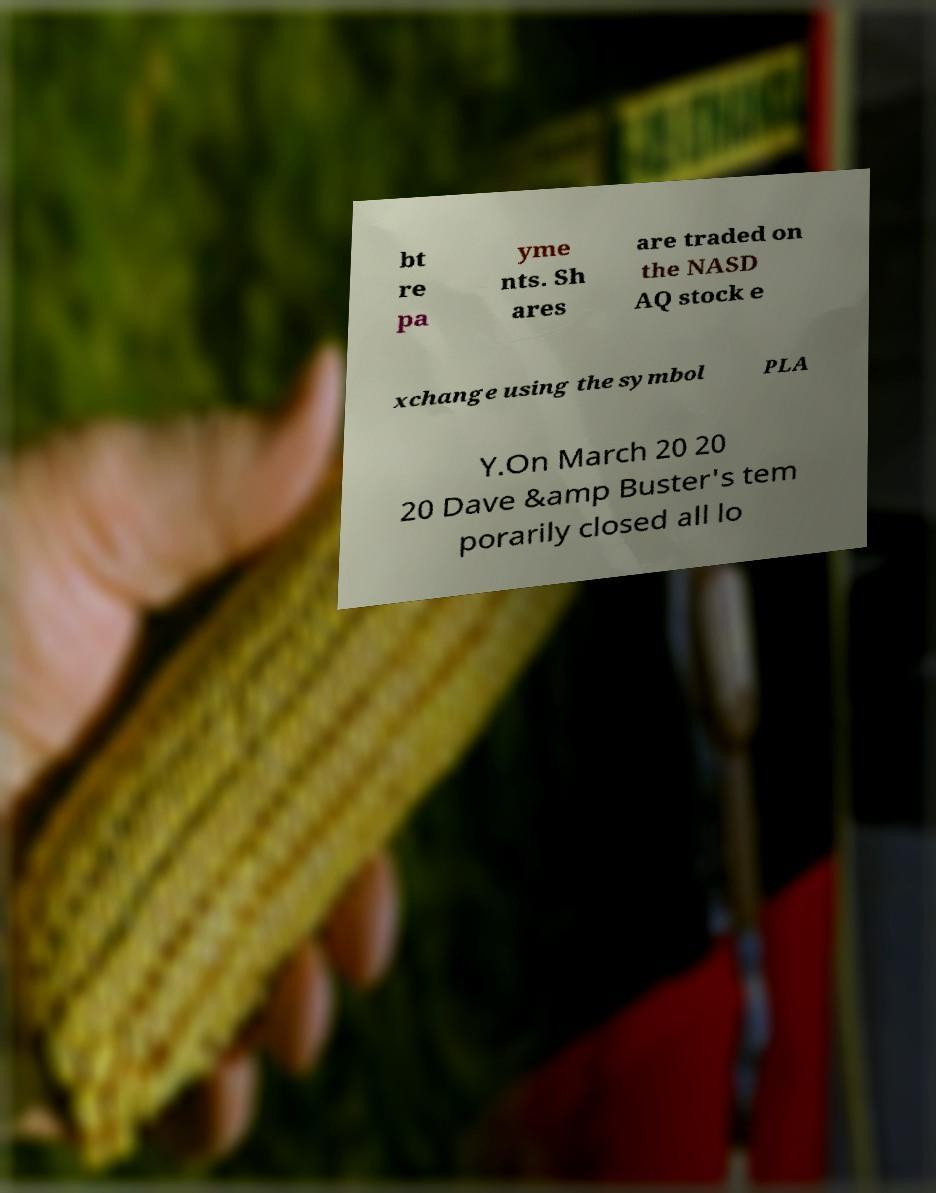Can you accurately transcribe the text from the provided image for me? bt re pa yme nts. Sh ares are traded on the NASD AQ stock e xchange using the symbol PLA Y.On March 20 20 20 Dave &amp Buster's tem porarily closed all lo 